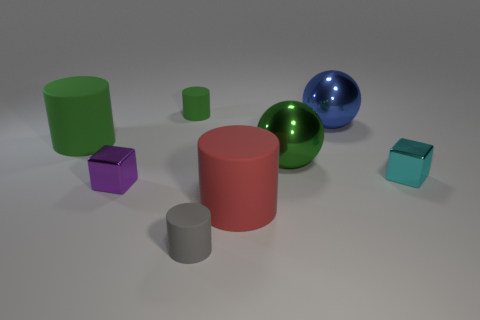Subtract all gray matte cylinders. How many cylinders are left? 3 Add 1 cyan shiny objects. How many objects exist? 9 Subtract all blue blocks. How many green cylinders are left? 2 Subtract all red cylinders. How many cylinders are left? 3 Subtract all gray balls. Subtract all green metallic spheres. How many objects are left? 7 Add 1 large blue metallic spheres. How many large blue metallic spheres are left? 2 Add 2 big metal balls. How many big metal balls exist? 4 Subtract 1 green cylinders. How many objects are left? 7 Subtract all balls. How many objects are left? 6 Subtract 2 cylinders. How many cylinders are left? 2 